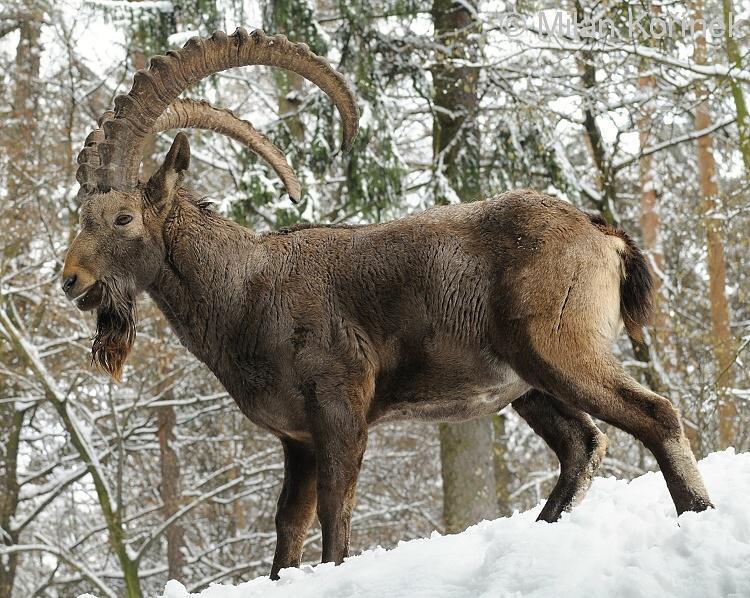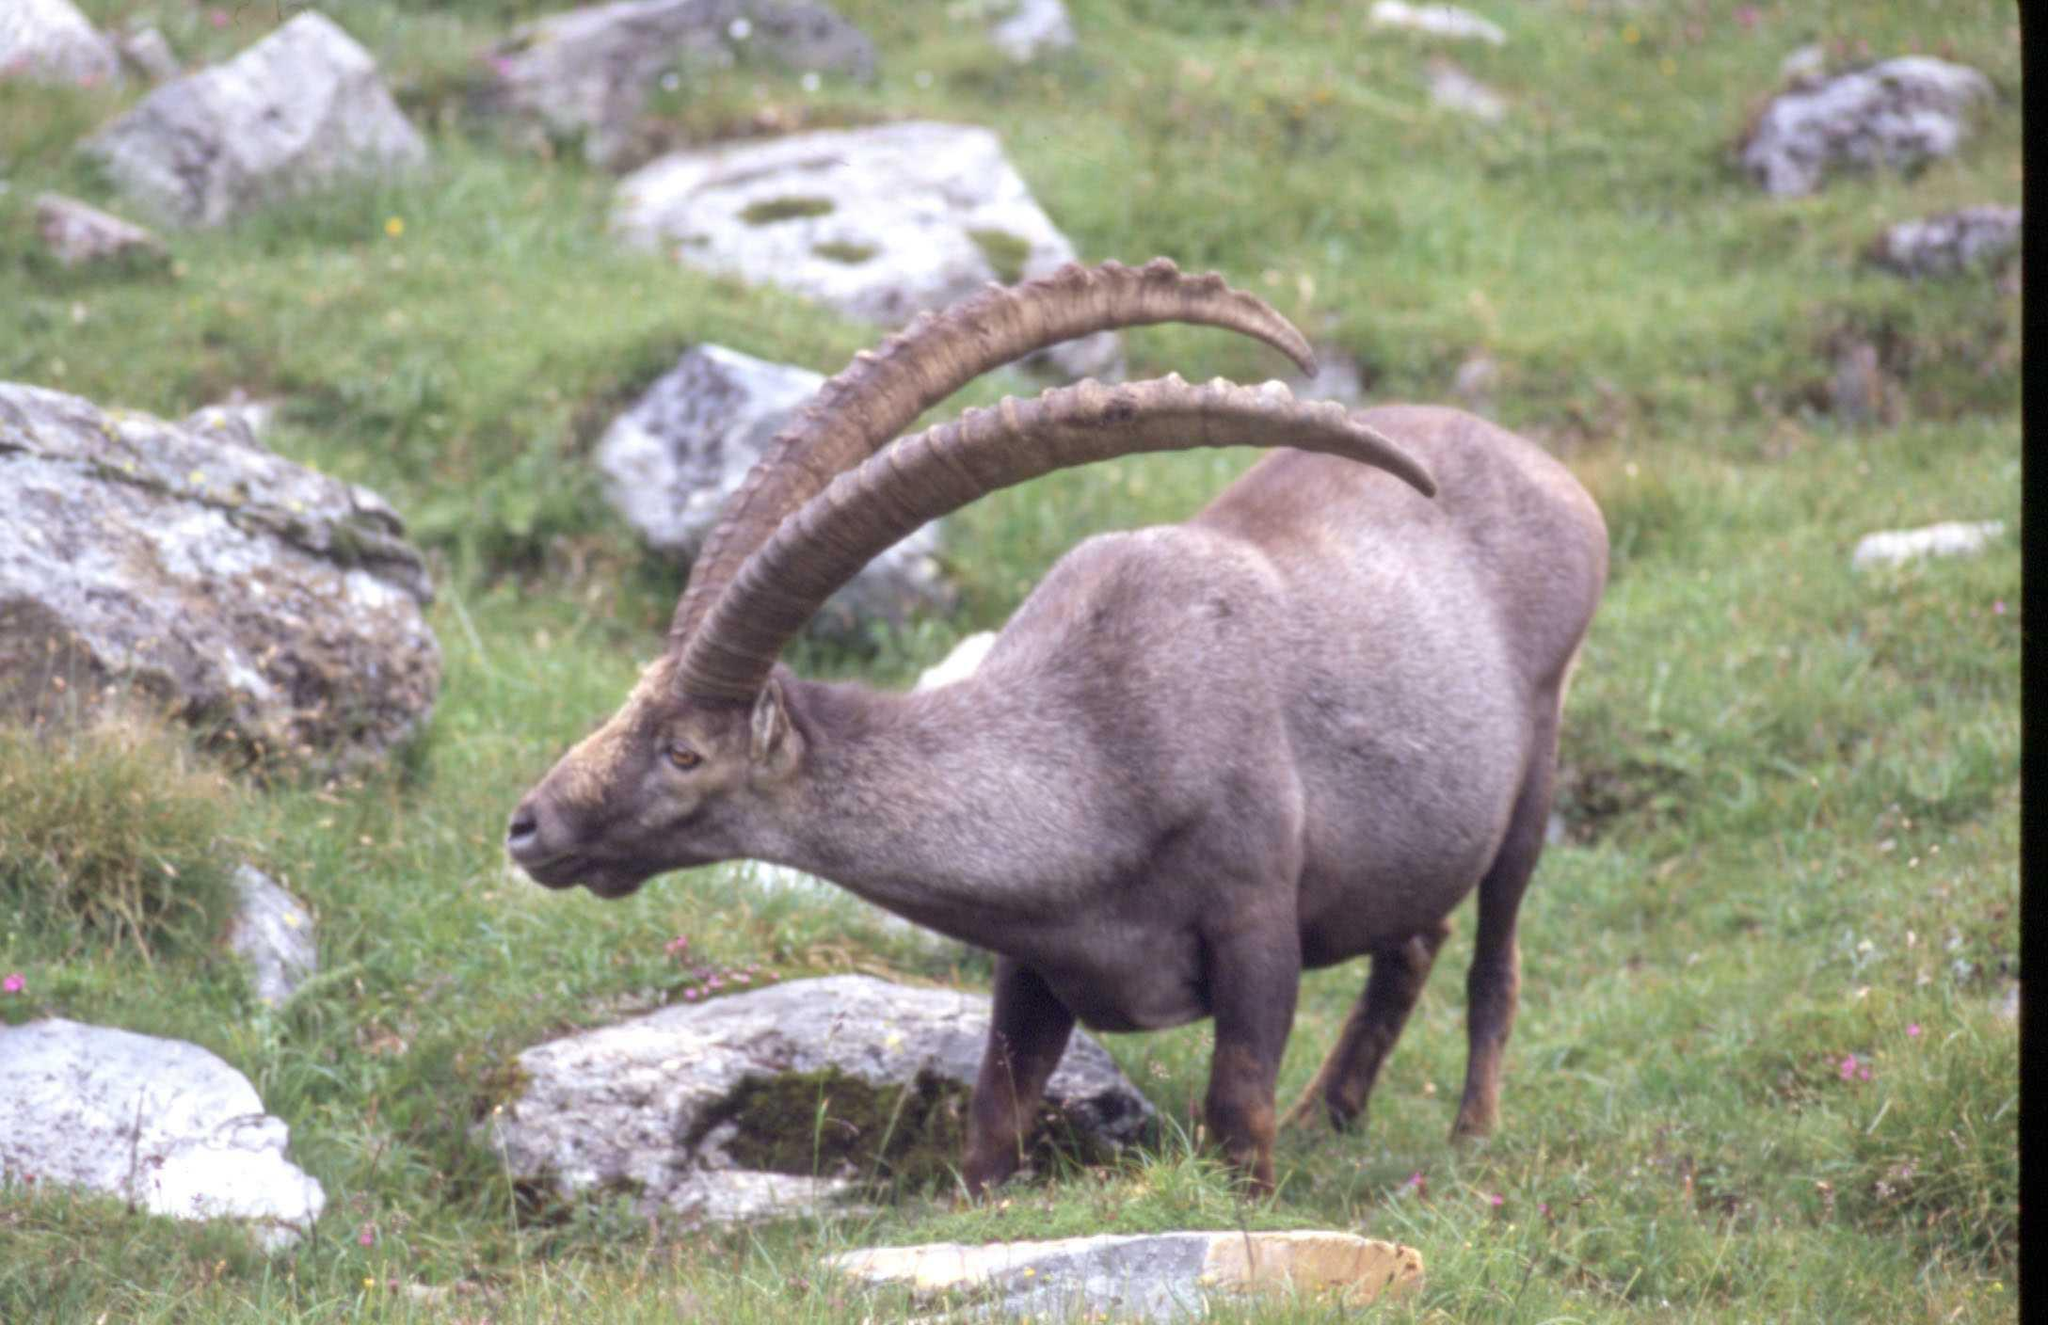The first image is the image on the left, the second image is the image on the right. Given the left and right images, does the statement "the animal on the right image is facing left" hold true? Answer yes or no. Yes. 